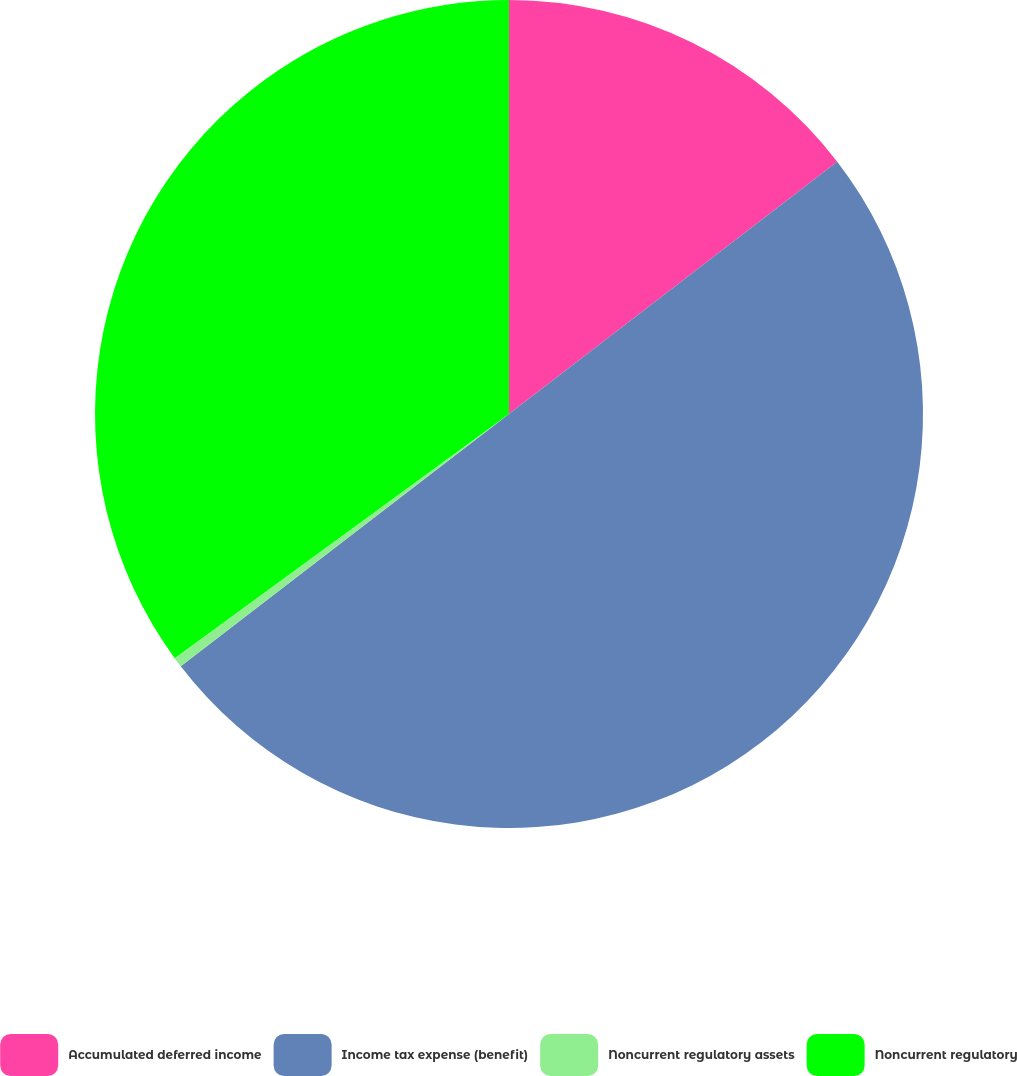<chart> <loc_0><loc_0><loc_500><loc_500><pie_chart><fcel>Accumulated deferred income<fcel>Income tax expense (benefit)<fcel>Noncurrent regulatory assets<fcel>Noncurrent regulatory<nl><fcel>14.57%<fcel>50.0%<fcel>0.39%<fcel>35.04%<nl></chart> 